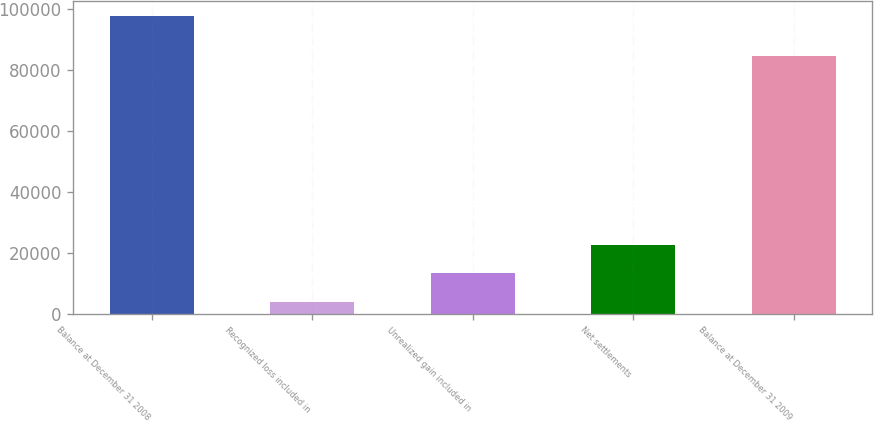Convert chart to OTSL. <chart><loc_0><loc_0><loc_500><loc_500><bar_chart><fcel>Balance at December 31 2008<fcel>Recognized loss included in<fcel>Unrealized gain included in<fcel>Net settlements<fcel>Balance at December 31 2009<nl><fcel>97617<fcel>3887<fcel>13260<fcel>22633<fcel>84325<nl></chart> 